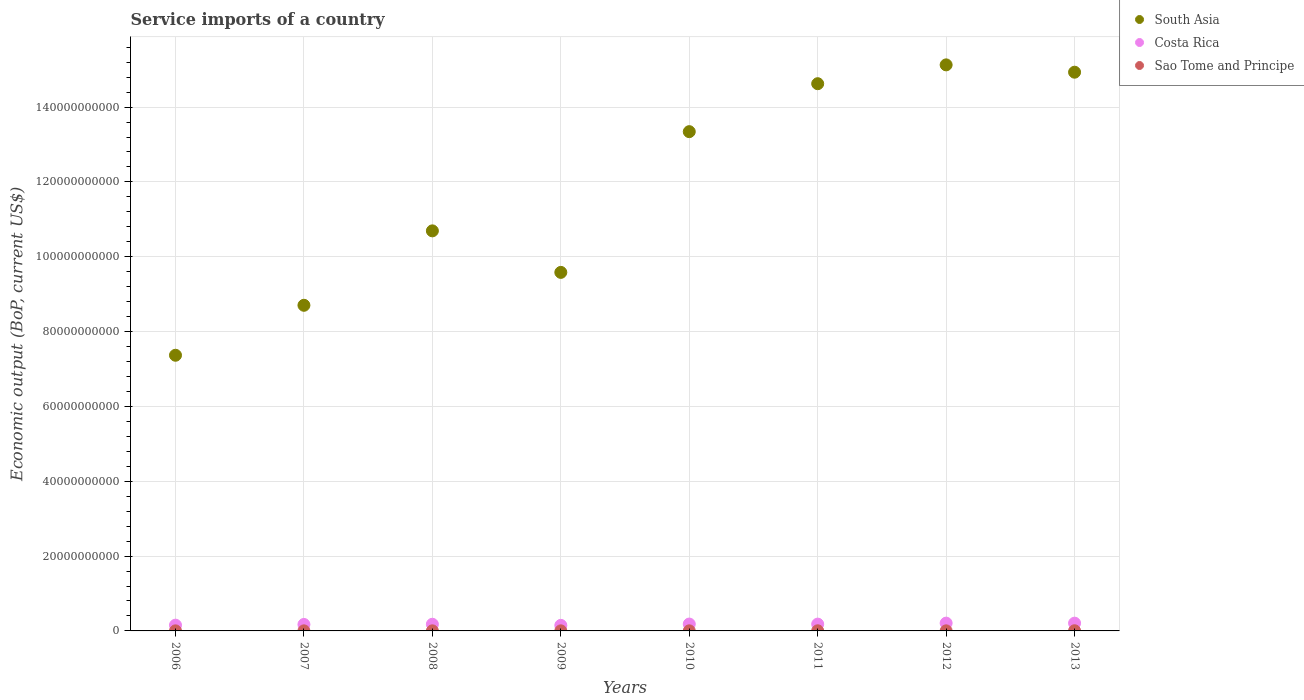How many different coloured dotlines are there?
Make the answer very short. 3. Is the number of dotlines equal to the number of legend labels?
Your response must be concise. Yes. What is the service imports in Costa Rica in 2006?
Keep it short and to the point. 1.54e+09. Across all years, what is the maximum service imports in Costa Rica?
Provide a succinct answer. 2.08e+09. Across all years, what is the minimum service imports in South Asia?
Give a very brief answer. 7.37e+1. In which year was the service imports in Costa Rica minimum?
Provide a short and direct response. 2009. What is the total service imports in Costa Rica in the graph?
Provide a succinct answer. 1.44e+1. What is the difference between the service imports in Costa Rica in 2008 and that in 2013?
Make the answer very short. -2.96e+08. What is the difference between the service imports in South Asia in 2011 and the service imports in Costa Rica in 2007?
Ensure brevity in your answer.  1.45e+11. What is the average service imports in Costa Rica per year?
Ensure brevity in your answer.  1.79e+09. In the year 2012, what is the difference between the service imports in South Asia and service imports in Costa Rica?
Provide a short and direct response. 1.49e+11. In how many years, is the service imports in South Asia greater than 116000000000 US$?
Keep it short and to the point. 4. What is the ratio of the service imports in South Asia in 2008 to that in 2012?
Your response must be concise. 0.71. Is the difference between the service imports in South Asia in 2008 and 2012 greater than the difference between the service imports in Costa Rica in 2008 and 2012?
Keep it short and to the point. No. What is the difference between the highest and the second highest service imports in Costa Rica?
Offer a terse response. 8.37e+06. What is the difference between the highest and the lowest service imports in Costa Rica?
Your answer should be compact. 5.97e+08. Is it the case that in every year, the sum of the service imports in South Asia and service imports in Sao Tome and Principe  is greater than the service imports in Costa Rica?
Ensure brevity in your answer.  Yes. How many years are there in the graph?
Ensure brevity in your answer.  8. Are the values on the major ticks of Y-axis written in scientific E-notation?
Keep it short and to the point. No. Does the graph contain any zero values?
Give a very brief answer. No. How many legend labels are there?
Your answer should be compact. 3. How are the legend labels stacked?
Your answer should be very brief. Vertical. What is the title of the graph?
Make the answer very short. Service imports of a country. Does "Mauritius" appear as one of the legend labels in the graph?
Offer a terse response. No. What is the label or title of the X-axis?
Give a very brief answer. Years. What is the label or title of the Y-axis?
Give a very brief answer. Economic output (BoP, current US$). What is the Economic output (BoP, current US$) in South Asia in 2006?
Offer a terse response. 7.37e+1. What is the Economic output (BoP, current US$) of Costa Rica in 2006?
Keep it short and to the point. 1.54e+09. What is the Economic output (BoP, current US$) in Sao Tome and Principe in 2006?
Offer a very short reply. 1.78e+07. What is the Economic output (BoP, current US$) of South Asia in 2007?
Make the answer very short. 8.70e+1. What is the Economic output (BoP, current US$) of Costa Rica in 2007?
Keep it short and to the point. 1.73e+09. What is the Economic output (BoP, current US$) of Sao Tome and Principe in 2007?
Give a very brief answer. 1.87e+07. What is the Economic output (BoP, current US$) in South Asia in 2008?
Offer a terse response. 1.07e+11. What is the Economic output (BoP, current US$) of Costa Rica in 2008?
Offer a very short reply. 1.78e+09. What is the Economic output (BoP, current US$) in Sao Tome and Principe in 2008?
Provide a short and direct response. 2.14e+07. What is the Economic output (BoP, current US$) in South Asia in 2009?
Give a very brief answer. 9.58e+1. What is the Economic output (BoP, current US$) of Costa Rica in 2009?
Offer a terse response. 1.49e+09. What is the Economic output (BoP, current US$) of Sao Tome and Principe in 2009?
Keep it short and to the point. 1.90e+07. What is the Economic output (BoP, current US$) in South Asia in 2010?
Your answer should be compact. 1.33e+11. What is the Economic output (BoP, current US$) in Costa Rica in 2010?
Provide a short and direct response. 1.84e+09. What is the Economic output (BoP, current US$) of Sao Tome and Principe in 2010?
Ensure brevity in your answer.  2.43e+07. What is the Economic output (BoP, current US$) of South Asia in 2011?
Your answer should be very brief. 1.46e+11. What is the Economic output (BoP, current US$) of Costa Rica in 2011?
Offer a very short reply. 1.82e+09. What is the Economic output (BoP, current US$) in Sao Tome and Principe in 2011?
Provide a succinct answer. 3.14e+07. What is the Economic output (BoP, current US$) in South Asia in 2012?
Ensure brevity in your answer.  1.51e+11. What is the Economic output (BoP, current US$) in Costa Rica in 2012?
Make the answer very short. 2.08e+09. What is the Economic output (BoP, current US$) in Sao Tome and Principe in 2012?
Your response must be concise. 2.46e+07. What is the Economic output (BoP, current US$) in South Asia in 2013?
Your answer should be compact. 1.49e+11. What is the Economic output (BoP, current US$) in Costa Rica in 2013?
Ensure brevity in your answer.  2.08e+09. What is the Economic output (BoP, current US$) in Sao Tome and Principe in 2013?
Keep it short and to the point. 4.49e+07. Across all years, what is the maximum Economic output (BoP, current US$) in South Asia?
Give a very brief answer. 1.51e+11. Across all years, what is the maximum Economic output (BoP, current US$) in Costa Rica?
Ensure brevity in your answer.  2.08e+09. Across all years, what is the maximum Economic output (BoP, current US$) of Sao Tome and Principe?
Your answer should be compact. 4.49e+07. Across all years, what is the minimum Economic output (BoP, current US$) of South Asia?
Ensure brevity in your answer.  7.37e+1. Across all years, what is the minimum Economic output (BoP, current US$) of Costa Rica?
Your response must be concise. 1.49e+09. Across all years, what is the minimum Economic output (BoP, current US$) of Sao Tome and Principe?
Give a very brief answer. 1.78e+07. What is the total Economic output (BoP, current US$) of South Asia in the graph?
Offer a very short reply. 9.44e+11. What is the total Economic output (BoP, current US$) in Costa Rica in the graph?
Keep it short and to the point. 1.44e+1. What is the total Economic output (BoP, current US$) in Sao Tome and Principe in the graph?
Provide a short and direct response. 2.02e+08. What is the difference between the Economic output (BoP, current US$) of South Asia in 2006 and that in 2007?
Your answer should be compact. -1.34e+1. What is the difference between the Economic output (BoP, current US$) in Costa Rica in 2006 and that in 2007?
Ensure brevity in your answer.  -1.88e+08. What is the difference between the Economic output (BoP, current US$) in Sao Tome and Principe in 2006 and that in 2007?
Your answer should be very brief. -9.06e+05. What is the difference between the Economic output (BoP, current US$) of South Asia in 2006 and that in 2008?
Provide a succinct answer. -3.32e+1. What is the difference between the Economic output (BoP, current US$) of Costa Rica in 2006 and that in 2008?
Ensure brevity in your answer.  -2.40e+08. What is the difference between the Economic output (BoP, current US$) in Sao Tome and Principe in 2006 and that in 2008?
Ensure brevity in your answer.  -3.68e+06. What is the difference between the Economic output (BoP, current US$) of South Asia in 2006 and that in 2009?
Your answer should be very brief. -2.21e+1. What is the difference between the Economic output (BoP, current US$) in Costa Rica in 2006 and that in 2009?
Your answer should be compact. 5.21e+07. What is the difference between the Economic output (BoP, current US$) of Sao Tome and Principe in 2006 and that in 2009?
Your answer should be very brief. -1.22e+06. What is the difference between the Economic output (BoP, current US$) of South Asia in 2006 and that in 2010?
Provide a short and direct response. -5.98e+1. What is the difference between the Economic output (BoP, current US$) in Costa Rica in 2006 and that in 2010?
Provide a short and direct response. -2.98e+08. What is the difference between the Economic output (BoP, current US$) of Sao Tome and Principe in 2006 and that in 2010?
Offer a terse response. -6.56e+06. What is the difference between the Economic output (BoP, current US$) in South Asia in 2006 and that in 2011?
Your response must be concise. -7.26e+1. What is the difference between the Economic output (BoP, current US$) in Costa Rica in 2006 and that in 2011?
Keep it short and to the point. -2.82e+08. What is the difference between the Economic output (BoP, current US$) of Sao Tome and Principe in 2006 and that in 2011?
Give a very brief answer. -1.36e+07. What is the difference between the Economic output (BoP, current US$) in South Asia in 2006 and that in 2012?
Offer a very short reply. -7.76e+1. What is the difference between the Economic output (BoP, current US$) in Costa Rica in 2006 and that in 2012?
Your answer should be very brief. -5.45e+08. What is the difference between the Economic output (BoP, current US$) in Sao Tome and Principe in 2006 and that in 2012?
Provide a succinct answer. -6.86e+06. What is the difference between the Economic output (BoP, current US$) of South Asia in 2006 and that in 2013?
Keep it short and to the point. -7.56e+1. What is the difference between the Economic output (BoP, current US$) of Costa Rica in 2006 and that in 2013?
Your answer should be very brief. -5.37e+08. What is the difference between the Economic output (BoP, current US$) in Sao Tome and Principe in 2006 and that in 2013?
Make the answer very short. -2.71e+07. What is the difference between the Economic output (BoP, current US$) in South Asia in 2007 and that in 2008?
Make the answer very short. -1.99e+1. What is the difference between the Economic output (BoP, current US$) of Costa Rica in 2007 and that in 2008?
Provide a short and direct response. -5.26e+07. What is the difference between the Economic output (BoP, current US$) in Sao Tome and Principe in 2007 and that in 2008?
Keep it short and to the point. -2.77e+06. What is the difference between the Economic output (BoP, current US$) of South Asia in 2007 and that in 2009?
Provide a short and direct response. -8.79e+09. What is the difference between the Economic output (BoP, current US$) in Costa Rica in 2007 and that in 2009?
Make the answer very short. 2.40e+08. What is the difference between the Economic output (BoP, current US$) in Sao Tome and Principe in 2007 and that in 2009?
Ensure brevity in your answer.  -3.17e+05. What is the difference between the Economic output (BoP, current US$) of South Asia in 2007 and that in 2010?
Give a very brief answer. -4.64e+1. What is the difference between the Economic output (BoP, current US$) in Costa Rica in 2007 and that in 2010?
Your response must be concise. -1.10e+08. What is the difference between the Economic output (BoP, current US$) of Sao Tome and Principe in 2007 and that in 2010?
Your answer should be very brief. -5.65e+06. What is the difference between the Economic output (BoP, current US$) in South Asia in 2007 and that in 2011?
Your answer should be compact. -5.92e+1. What is the difference between the Economic output (BoP, current US$) of Costa Rica in 2007 and that in 2011?
Give a very brief answer. -9.42e+07. What is the difference between the Economic output (BoP, current US$) in Sao Tome and Principe in 2007 and that in 2011?
Your answer should be compact. -1.27e+07. What is the difference between the Economic output (BoP, current US$) of South Asia in 2007 and that in 2012?
Offer a very short reply. -6.43e+1. What is the difference between the Economic output (BoP, current US$) in Costa Rica in 2007 and that in 2012?
Make the answer very short. -3.57e+08. What is the difference between the Economic output (BoP, current US$) in Sao Tome and Principe in 2007 and that in 2012?
Ensure brevity in your answer.  -5.95e+06. What is the difference between the Economic output (BoP, current US$) in South Asia in 2007 and that in 2013?
Ensure brevity in your answer.  -6.23e+1. What is the difference between the Economic output (BoP, current US$) in Costa Rica in 2007 and that in 2013?
Keep it short and to the point. -3.49e+08. What is the difference between the Economic output (BoP, current US$) of Sao Tome and Principe in 2007 and that in 2013?
Offer a very short reply. -2.62e+07. What is the difference between the Economic output (BoP, current US$) in South Asia in 2008 and that in 2009?
Provide a short and direct response. 1.11e+1. What is the difference between the Economic output (BoP, current US$) in Costa Rica in 2008 and that in 2009?
Your answer should be very brief. 2.92e+08. What is the difference between the Economic output (BoP, current US$) in Sao Tome and Principe in 2008 and that in 2009?
Offer a terse response. 2.45e+06. What is the difference between the Economic output (BoP, current US$) in South Asia in 2008 and that in 2010?
Ensure brevity in your answer.  -2.65e+1. What is the difference between the Economic output (BoP, current US$) of Costa Rica in 2008 and that in 2010?
Provide a succinct answer. -5.72e+07. What is the difference between the Economic output (BoP, current US$) in Sao Tome and Principe in 2008 and that in 2010?
Your response must be concise. -2.88e+06. What is the difference between the Economic output (BoP, current US$) of South Asia in 2008 and that in 2011?
Ensure brevity in your answer.  -3.93e+1. What is the difference between the Economic output (BoP, current US$) of Costa Rica in 2008 and that in 2011?
Your answer should be very brief. -4.16e+07. What is the difference between the Economic output (BoP, current US$) in Sao Tome and Principe in 2008 and that in 2011?
Ensure brevity in your answer.  -9.96e+06. What is the difference between the Economic output (BoP, current US$) in South Asia in 2008 and that in 2012?
Give a very brief answer. -4.44e+1. What is the difference between the Economic output (BoP, current US$) of Costa Rica in 2008 and that in 2012?
Your response must be concise. -3.05e+08. What is the difference between the Economic output (BoP, current US$) of Sao Tome and Principe in 2008 and that in 2012?
Offer a very short reply. -3.18e+06. What is the difference between the Economic output (BoP, current US$) of South Asia in 2008 and that in 2013?
Ensure brevity in your answer.  -4.24e+1. What is the difference between the Economic output (BoP, current US$) of Costa Rica in 2008 and that in 2013?
Provide a succinct answer. -2.96e+08. What is the difference between the Economic output (BoP, current US$) of Sao Tome and Principe in 2008 and that in 2013?
Your answer should be very brief. -2.34e+07. What is the difference between the Economic output (BoP, current US$) of South Asia in 2009 and that in 2010?
Provide a short and direct response. -3.76e+1. What is the difference between the Economic output (BoP, current US$) of Costa Rica in 2009 and that in 2010?
Offer a very short reply. -3.50e+08. What is the difference between the Economic output (BoP, current US$) of Sao Tome and Principe in 2009 and that in 2010?
Offer a very short reply. -5.34e+06. What is the difference between the Economic output (BoP, current US$) in South Asia in 2009 and that in 2011?
Provide a succinct answer. -5.04e+1. What is the difference between the Economic output (BoP, current US$) of Costa Rica in 2009 and that in 2011?
Provide a succinct answer. -3.34e+08. What is the difference between the Economic output (BoP, current US$) in Sao Tome and Principe in 2009 and that in 2011?
Give a very brief answer. -1.24e+07. What is the difference between the Economic output (BoP, current US$) in South Asia in 2009 and that in 2012?
Provide a succinct answer. -5.55e+1. What is the difference between the Economic output (BoP, current US$) of Costa Rica in 2009 and that in 2012?
Offer a very short reply. -5.97e+08. What is the difference between the Economic output (BoP, current US$) in Sao Tome and Principe in 2009 and that in 2012?
Ensure brevity in your answer.  -5.64e+06. What is the difference between the Economic output (BoP, current US$) in South Asia in 2009 and that in 2013?
Your response must be concise. -5.35e+1. What is the difference between the Economic output (BoP, current US$) in Costa Rica in 2009 and that in 2013?
Give a very brief answer. -5.89e+08. What is the difference between the Economic output (BoP, current US$) in Sao Tome and Principe in 2009 and that in 2013?
Offer a very short reply. -2.59e+07. What is the difference between the Economic output (BoP, current US$) of South Asia in 2010 and that in 2011?
Give a very brief answer. -1.28e+1. What is the difference between the Economic output (BoP, current US$) of Costa Rica in 2010 and that in 2011?
Provide a succinct answer. 1.56e+07. What is the difference between the Economic output (BoP, current US$) in Sao Tome and Principe in 2010 and that in 2011?
Your response must be concise. -7.08e+06. What is the difference between the Economic output (BoP, current US$) of South Asia in 2010 and that in 2012?
Provide a succinct answer. -1.78e+1. What is the difference between the Economic output (BoP, current US$) in Costa Rica in 2010 and that in 2012?
Your response must be concise. -2.47e+08. What is the difference between the Economic output (BoP, current US$) in Sao Tome and Principe in 2010 and that in 2012?
Your answer should be very brief. -2.99e+05. What is the difference between the Economic output (BoP, current US$) of South Asia in 2010 and that in 2013?
Provide a short and direct response. -1.59e+1. What is the difference between the Economic output (BoP, current US$) of Costa Rica in 2010 and that in 2013?
Your answer should be very brief. -2.39e+08. What is the difference between the Economic output (BoP, current US$) of Sao Tome and Principe in 2010 and that in 2013?
Keep it short and to the point. -2.06e+07. What is the difference between the Economic output (BoP, current US$) in South Asia in 2011 and that in 2012?
Give a very brief answer. -5.03e+09. What is the difference between the Economic output (BoP, current US$) in Costa Rica in 2011 and that in 2012?
Your response must be concise. -2.63e+08. What is the difference between the Economic output (BoP, current US$) in Sao Tome and Principe in 2011 and that in 2012?
Ensure brevity in your answer.  6.78e+06. What is the difference between the Economic output (BoP, current US$) of South Asia in 2011 and that in 2013?
Give a very brief answer. -3.07e+09. What is the difference between the Economic output (BoP, current US$) in Costa Rica in 2011 and that in 2013?
Offer a very short reply. -2.55e+08. What is the difference between the Economic output (BoP, current US$) in Sao Tome and Principe in 2011 and that in 2013?
Offer a terse response. -1.35e+07. What is the difference between the Economic output (BoP, current US$) in South Asia in 2012 and that in 2013?
Ensure brevity in your answer.  1.96e+09. What is the difference between the Economic output (BoP, current US$) of Costa Rica in 2012 and that in 2013?
Your answer should be compact. 8.37e+06. What is the difference between the Economic output (BoP, current US$) in Sao Tome and Principe in 2012 and that in 2013?
Your answer should be very brief. -2.03e+07. What is the difference between the Economic output (BoP, current US$) in South Asia in 2006 and the Economic output (BoP, current US$) in Costa Rica in 2007?
Offer a terse response. 7.19e+1. What is the difference between the Economic output (BoP, current US$) of South Asia in 2006 and the Economic output (BoP, current US$) of Sao Tome and Principe in 2007?
Make the answer very short. 7.37e+1. What is the difference between the Economic output (BoP, current US$) in Costa Rica in 2006 and the Economic output (BoP, current US$) in Sao Tome and Principe in 2007?
Offer a very short reply. 1.52e+09. What is the difference between the Economic output (BoP, current US$) in South Asia in 2006 and the Economic output (BoP, current US$) in Costa Rica in 2008?
Keep it short and to the point. 7.19e+1. What is the difference between the Economic output (BoP, current US$) in South Asia in 2006 and the Economic output (BoP, current US$) in Sao Tome and Principe in 2008?
Keep it short and to the point. 7.37e+1. What is the difference between the Economic output (BoP, current US$) of Costa Rica in 2006 and the Economic output (BoP, current US$) of Sao Tome and Principe in 2008?
Ensure brevity in your answer.  1.52e+09. What is the difference between the Economic output (BoP, current US$) in South Asia in 2006 and the Economic output (BoP, current US$) in Costa Rica in 2009?
Provide a succinct answer. 7.22e+1. What is the difference between the Economic output (BoP, current US$) of South Asia in 2006 and the Economic output (BoP, current US$) of Sao Tome and Principe in 2009?
Your answer should be very brief. 7.37e+1. What is the difference between the Economic output (BoP, current US$) in Costa Rica in 2006 and the Economic output (BoP, current US$) in Sao Tome and Principe in 2009?
Make the answer very short. 1.52e+09. What is the difference between the Economic output (BoP, current US$) of South Asia in 2006 and the Economic output (BoP, current US$) of Costa Rica in 2010?
Your response must be concise. 7.18e+1. What is the difference between the Economic output (BoP, current US$) in South Asia in 2006 and the Economic output (BoP, current US$) in Sao Tome and Principe in 2010?
Offer a very short reply. 7.37e+1. What is the difference between the Economic output (BoP, current US$) of Costa Rica in 2006 and the Economic output (BoP, current US$) of Sao Tome and Principe in 2010?
Offer a very short reply. 1.51e+09. What is the difference between the Economic output (BoP, current US$) of South Asia in 2006 and the Economic output (BoP, current US$) of Costa Rica in 2011?
Your response must be concise. 7.19e+1. What is the difference between the Economic output (BoP, current US$) of South Asia in 2006 and the Economic output (BoP, current US$) of Sao Tome and Principe in 2011?
Provide a succinct answer. 7.36e+1. What is the difference between the Economic output (BoP, current US$) in Costa Rica in 2006 and the Economic output (BoP, current US$) in Sao Tome and Principe in 2011?
Offer a very short reply. 1.51e+09. What is the difference between the Economic output (BoP, current US$) in South Asia in 2006 and the Economic output (BoP, current US$) in Costa Rica in 2012?
Your answer should be compact. 7.16e+1. What is the difference between the Economic output (BoP, current US$) in South Asia in 2006 and the Economic output (BoP, current US$) in Sao Tome and Principe in 2012?
Your answer should be compact. 7.37e+1. What is the difference between the Economic output (BoP, current US$) of Costa Rica in 2006 and the Economic output (BoP, current US$) of Sao Tome and Principe in 2012?
Keep it short and to the point. 1.51e+09. What is the difference between the Economic output (BoP, current US$) of South Asia in 2006 and the Economic output (BoP, current US$) of Costa Rica in 2013?
Offer a very short reply. 7.16e+1. What is the difference between the Economic output (BoP, current US$) of South Asia in 2006 and the Economic output (BoP, current US$) of Sao Tome and Principe in 2013?
Provide a short and direct response. 7.36e+1. What is the difference between the Economic output (BoP, current US$) of Costa Rica in 2006 and the Economic output (BoP, current US$) of Sao Tome and Principe in 2013?
Your response must be concise. 1.49e+09. What is the difference between the Economic output (BoP, current US$) in South Asia in 2007 and the Economic output (BoP, current US$) in Costa Rica in 2008?
Give a very brief answer. 8.53e+1. What is the difference between the Economic output (BoP, current US$) in South Asia in 2007 and the Economic output (BoP, current US$) in Sao Tome and Principe in 2008?
Give a very brief answer. 8.70e+1. What is the difference between the Economic output (BoP, current US$) in Costa Rica in 2007 and the Economic output (BoP, current US$) in Sao Tome and Principe in 2008?
Provide a succinct answer. 1.71e+09. What is the difference between the Economic output (BoP, current US$) of South Asia in 2007 and the Economic output (BoP, current US$) of Costa Rica in 2009?
Offer a terse response. 8.55e+1. What is the difference between the Economic output (BoP, current US$) of South Asia in 2007 and the Economic output (BoP, current US$) of Sao Tome and Principe in 2009?
Ensure brevity in your answer.  8.70e+1. What is the difference between the Economic output (BoP, current US$) in Costa Rica in 2007 and the Economic output (BoP, current US$) in Sao Tome and Principe in 2009?
Provide a succinct answer. 1.71e+09. What is the difference between the Economic output (BoP, current US$) in South Asia in 2007 and the Economic output (BoP, current US$) in Costa Rica in 2010?
Your response must be concise. 8.52e+1. What is the difference between the Economic output (BoP, current US$) in South Asia in 2007 and the Economic output (BoP, current US$) in Sao Tome and Principe in 2010?
Ensure brevity in your answer.  8.70e+1. What is the difference between the Economic output (BoP, current US$) in Costa Rica in 2007 and the Economic output (BoP, current US$) in Sao Tome and Principe in 2010?
Provide a short and direct response. 1.70e+09. What is the difference between the Economic output (BoP, current US$) of South Asia in 2007 and the Economic output (BoP, current US$) of Costa Rica in 2011?
Provide a succinct answer. 8.52e+1. What is the difference between the Economic output (BoP, current US$) of South Asia in 2007 and the Economic output (BoP, current US$) of Sao Tome and Principe in 2011?
Provide a short and direct response. 8.70e+1. What is the difference between the Economic output (BoP, current US$) of Costa Rica in 2007 and the Economic output (BoP, current US$) of Sao Tome and Principe in 2011?
Provide a succinct answer. 1.70e+09. What is the difference between the Economic output (BoP, current US$) of South Asia in 2007 and the Economic output (BoP, current US$) of Costa Rica in 2012?
Provide a short and direct response. 8.49e+1. What is the difference between the Economic output (BoP, current US$) of South Asia in 2007 and the Economic output (BoP, current US$) of Sao Tome and Principe in 2012?
Make the answer very short. 8.70e+1. What is the difference between the Economic output (BoP, current US$) in Costa Rica in 2007 and the Economic output (BoP, current US$) in Sao Tome and Principe in 2012?
Ensure brevity in your answer.  1.70e+09. What is the difference between the Economic output (BoP, current US$) in South Asia in 2007 and the Economic output (BoP, current US$) in Costa Rica in 2013?
Provide a succinct answer. 8.50e+1. What is the difference between the Economic output (BoP, current US$) of South Asia in 2007 and the Economic output (BoP, current US$) of Sao Tome and Principe in 2013?
Your answer should be very brief. 8.70e+1. What is the difference between the Economic output (BoP, current US$) in Costa Rica in 2007 and the Economic output (BoP, current US$) in Sao Tome and Principe in 2013?
Your answer should be compact. 1.68e+09. What is the difference between the Economic output (BoP, current US$) in South Asia in 2008 and the Economic output (BoP, current US$) in Costa Rica in 2009?
Provide a short and direct response. 1.05e+11. What is the difference between the Economic output (BoP, current US$) in South Asia in 2008 and the Economic output (BoP, current US$) in Sao Tome and Principe in 2009?
Keep it short and to the point. 1.07e+11. What is the difference between the Economic output (BoP, current US$) in Costa Rica in 2008 and the Economic output (BoP, current US$) in Sao Tome and Principe in 2009?
Keep it short and to the point. 1.76e+09. What is the difference between the Economic output (BoP, current US$) in South Asia in 2008 and the Economic output (BoP, current US$) in Costa Rica in 2010?
Your answer should be compact. 1.05e+11. What is the difference between the Economic output (BoP, current US$) in South Asia in 2008 and the Economic output (BoP, current US$) in Sao Tome and Principe in 2010?
Keep it short and to the point. 1.07e+11. What is the difference between the Economic output (BoP, current US$) of Costa Rica in 2008 and the Economic output (BoP, current US$) of Sao Tome and Principe in 2010?
Make the answer very short. 1.76e+09. What is the difference between the Economic output (BoP, current US$) of South Asia in 2008 and the Economic output (BoP, current US$) of Costa Rica in 2011?
Provide a short and direct response. 1.05e+11. What is the difference between the Economic output (BoP, current US$) in South Asia in 2008 and the Economic output (BoP, current US$) in Sao Tome and Principe in 2011?
Offer a terse response. 1.07e+11. What is the difference between the Economic output (BoP, current US$) in Costa Rica in 2008 and the Economic output (BoP, current US$) in Sao Tome and Principe in 2011?
Offer a terse response. 1.75e+09. What is the difference between the Economic output (BoP, current US$) in South Asia in 2008 and the Economic output (BoP, current US$) in Costa Rica in 2012?
Offer a terse response. 1.05e+11. What is the difference between the Economic output (BoP, current US$) in South Asia in 2008 and the Economic output (BoP, current US$) in Sao Tome and Principe in 2012?
Keep it short and to the point. 1.07e+11. What is the difference between the Economic output (BoP, current US$) of Costa Rica in 2008 and the Economic output (BoP, current US$) of Sao Tome and Principe in 2012?
Your answer should be compact. 1.75e+09. What is the difference between the Economic output (BoP, current US$) of South Asia in 2008 and the Economic output (BoP, current US$) of Costa Rica in 2013?
Offer a very short reply. 1.05e+11. What is the difference between the Economic output (BoP, current US$) of South Asia in 2008 and the Economic output (BoP, current US$) of Sao Tome and Principe in 2013?
Your answer should be very brief. 1.07e+11. What is the difference between the Economic output (BoP, current US$) in Costa Rica in 2008 and the Economic output (BoP, current US$) in Sao Tome and Principe in 2013?
Your answer should be compact. 1.73e+09. What is the difference between the Economic output (BoP, current US$) in South Asia in 2009 and the Economic output (BoP, current US$) in Costa Rica in 2010?
Give a very brief answer. 9.40e+1. What is the difference between the Economic output (BoP, current US$) of South Asia in 2009 and the Economic output (BoP, current US$) of Sao Tome and Principe in 2010?
Your answer should be very brief. 9.58e+1. What is the difference between the Economic output (BoP, current US$) of Costa Rica in 2009 and the Economic output (BoP, current US$) of Sao Tome and Principe in 2010?
Provide a short and direct response. 1.46e+09. What is the difference between the Economic output (BoP, current US$) of South Asia in 2009 and the Economic output (BoP, current US$) of Costa Rica in 2011?
Offer a very short reply. 9.40e+1. What is the difference between the Economic output (BoP, current US$) of South Asia in 2009 and the Economic output (BoP, current US$) of Sao Tome and Principe in 2011?
Provide a short and direct response. 9.58e+1. What is the difference between the Economic output (BoP, current US$) of Costa Rica in 2009 and the Economic output (BoP, current US$) of Sao Tome and Principe in 2011?
Offer a terse response. 1.46e+09. What is the difference between the Economic output (BoP, current US$) of South Asia in 2009 and the Economic output (BoP, current US$) of Costa Rica in 2012?
Offer a terse response. 9.37e+1. What is the difference between the Economic output (BoP, current US$) in South Asia in 2009 and the Economic output (BoP, current US$) in Sao Tome and Principe in 2012?
Your answer should be very brief. 9.58e+1. What is the difference between the Economic output (BoP, current US$) in Costa Rica in 2009 and the Economic output (BoP, current US$) in Sao Tome and Principe in 2012?
Provide a short and direct response. 1.46e+09. What is the difference between the Economic output (BoP, current US$) in South Asia in 2009 and the Economic output (BoP, current US$) in Costa Rica in 2013?
Offer a terse response. 9.37e+1. What is the difference between the Economic output (BoP, current US$) in South Asia in 2009 and the Economic output (BoP, current US$) in Sao Tome and Principe in 2013?
Give a very brief answer. 9.58e+1. What is the difference between the Economic output (BoP, current US$) of Costa Rica in 2009 and the Economic output (BoP, current US$) of Sao Tome and Principe in 2013?
Ensure brevity in your answer.  1.44e+09. What is the difference between the Economic output (BoP, current US$) of South Asia in 2010 and the Economic output (BoP, current US$) of Costa Rica in 2011?
Offer a very short reply. 1.32e+11. What is the difference between the Economic output (BoP, current US$) in South Asia in 2010 and the Economic output (BoP, current US$) in Sao Tome and Principe in 2011?
Offer a very short reply. 1.33e+11. What is the difference between the Economic output (BoP, current US$) of Costa Rica in 2010 and the Economic output (BoP, current US$) of Sao Tome and Principe in 2011?
Provide a succinct answer. 1.81e+09. What is the difference between the Economic output (BoP, current US$) of South Asia in 2010 and the Economic output (BoP, current US$) of Costa Rica in 2012?
Keep it short and to the point. 1.31e+11. What is the difference between the Economic output (BoP, current US$) of South Asia in 2010 and the Economic output (BoP, current US$) of Sao Tome and Principe in 2012?
Provide a succinct answer. 1.33e+11. What is the difference between the Economic output (BoP, current US$) in Costa Rica in 2010 and the Economic output (BoP, current US$) in Sao Tome and Principe in 2012?
Provide a short and direct response. 1.81e+09. What is the difference between the Economic output (BoP, current US$) in South Asia in 2010 and the Economic output (BoP, current US$) in Costa Rica in 2013?
Give a very brief answer. 1.31e+11. What is the difference between the Economic output (BoP, current US$) in South Asia in 2010 and the Economic output (BoP, current US$) in Sao Tome and Principe in 2013?
Make the answer very short. 1.33e+11. What is the difference between the Economic output (BoP, current US$) of Costa Rica in 2010 and the Economic output (BoP, current US$) of Sao Tome and Principe in 2013?
Your answer should be very brief. 1.79e+09. What is the difference between the Economic output (BoP, current US$) of South Asia in 2011 and the Economic output (BoP, current US$) of Costa Rica in 2012?
Your answer should be very brief. 1.44e+11. What is the difference between the Economic output (BoP, current US$) of South Asia in 2011 and the Economic output (BoP, current US$) of Sao Tome and Principe in 2012?
Offer a terse response. 1.46e+11. What is the difference between the Economic output (BoP, current US$) in Costa Rica in 2011 and the Economic output (BoP, current US$) in Sao Tome and Principe in 2012?
Offer a very short reply. 1.80e+09. What is the difference between the Economic output (BoP, current US$) of South Asia in 2011 and the Economic output (BoP, current US$) of Costa Rica in 2013?
Your response must be concise. 1.44e+11. What is the difference between the Economic output (BoP, current US$) in South Asia in 2011 and the Economic output (BoP, current US$) in Sao Tome and Principe in 2013?
Make the answer very short. 1.46e+11. What is the difference between the Economic output (BoP, current US$) of Costa Rica in 2011 and the Economic output (BoP, current US$) of Sao Tome and Principe in 2013?
Provide a succinct answer. 1.78e+09. What is the difference between the Economic output (BoP, current US$) of South Asia in 2012 and the Economic output (BoP, current US$) of Costa Rica in 2013?
Your answer should be compact. 1.49e+11. What is the difference between the Economic output (BoP, current US$) in South Asia in 2012 and the Economic output (BoP, current US$) in Sao Tome and Principe in 2013?
Offer a terse response. 1.51e+11. What is the difference between the Economic output (BoP, current US$) of Costa Rica in 2012 and the Economic output (BoP, current US$) of Sao Tome and Principe in 2013?
Your response must be concise. 2.04e+09. What is the average Economic output (BoP, current US$) of South Asia per year?
Provide a succinct answer. 1.18e+11. What is the average Economic output (BoP, current US$) of Costa Rica per year?
Your answer should be compact. 1.79e+09. What is the average Economic output (BoP, current US$) of Sao Tome and Principe per year?
Provide a succinct answer. 2.53e+07. In the year 2006, what is the difference between the Economic output (BoP, current US$) in South Asia and Economic output (BoP, current US$) in Costa Rica?
Your answer should be compact. 7.21e+1. In the year 2006, what is the difference between the Economic output (BoP, current US$) of South Asia and Economic output (BoP, current US$) of Sao Tome and Principe?
Your answer should be very brief. 7.37e+1. In the year 2006, what is the difference between the Economic output (BoP, current US$) in Costa Rica and Economic output (BoP, current US$) in Sao Tome and Principe?
Offer a terse response. 1.52e+09. In the year 2007, what is the difference between the Economic output (BoP, current US$) in South Asia and Economic output (BoP, current US$) in Costa Rica?
Your response must be concise. 8.53e+1. In the year 2007, what is the difference between the Economic output (BoP, current US$) in South Asia and Economic output (BoP, current US$) in Sao Tome and Principe?
Make the answer very short. 8.70e+1. In the year 2007, what is the difference between the Economic output (BoP, current US$) of Costa Rica and Economic output (BoP, current US$) of Sao Tome and Principe?
Make the answer very short. 1.71e+09. In the year 2008, what is the difference between the Economic output (BoP, current US$) of South Asia and Economic output (BoP, current US$) of Costa Rica?
Offer a terse response. 1.05e+11. In the year 2008, what is the difference between the Economic output (BoP, current US$) of South Asia and Economic output (BoP, current US$) of Sao Tome and Principe?
Ensure brevity in your answer.  1.07e+11. In the year 2008, what is the difference between the Economic output (BoP, current US$) of Costa Rica and Economic output (BoP, current US$) of Sao Tome and Principe?
Provide a succinct answer. 1.76e+09. In the year 2009, what is the difference between the Economic output (BoP, current US$) in South Asia and Economic output (BoP, current US$) in Costa Rica?
Your answer should be compact. 9.43e+1. In the year 2009, what is the difference between the Economic output (BoP, current US$) of South Asia and Economic output (BoP, current US$) of Sao Tome and Principe?
Your answer should be compact. 9.58e+1. In the year 2009, what is the difference between the Economic output (BoP, current US$) in Costa Rica and Economic output (BoP, current US$) in Sao Tome and Principe?
Make the answer very short. 1.47e+09. In the year 2010, what is the difference between the Economic output (BoP, current US$) of South Asia and Economic output (BoP, current US$) of Costa Rica?
Give a very brief answer. 1.32e+11. In the year 2010, what is the difference between the Economic output (BoP, current US$) of South Asia and Economic output (BoP, current US$) of Sao Tome and Principe?
Offer a terse response. 1.33e+11. In the year 2010, what is the difference between the Economic output (BoP, current US$) of Costa Rica and Economic output (BoP, current US$) of Sao Tome and Principe?
Give a very brief answer. 1.81e+09. In the year 2011, what is the difference between the Economic output (BoP, current US$) of South Asia and Economic output (BoP, current US$) of Costa Rica?
Offer a very short reply. 1.44e+11. In the year 2011, what is the difference between the Economic output (BoP, current US$) of South Asia and Economic output (BoP, current US$) of Sao Tome and Principe?
Ensure brevity in your answer.  1.46e+11. In the year 2011, what is the difference between the Economic output (BoP, current US$) in Costa Rica and Economic output (BoP, current US$) in Sao Tome and Principe?
Your response must be concise. 1.79e+09. In the year 2012, what is the difference between the Economic output (BoP, current US$) of South Asia and Economic output (BoP, current US$) of Costa Rica?
Your answer should be compact. 1.49e+11. In the year 2012, what is the difference between the Economic output (BoP, current US$) of South Asia and Economic output (BoP, current US$) of Sao Tome and Principe?
Ensure brevity in your answer.  1.51e+11. In the year 2012, what is the difference between the Economic output (BoP, current US$) in Costa Rica and Economic output (BoP, current US$) in Sao Tome and Principe?
Make the answer very short. 2.06e+09. In the year 2013, what is the difference between the Economic output (BoP, current US$) of South Asia and Economic output (BoP, current US$) of Costa Rica?
Ensure brevity in your answer.  1.47e+11. In the year 2013, what is the difference between the Economic output (BoP, current US$) in South Asia and Economic output (BoP, current US$) in Sao Tome and Principe?
Keep it short and to the point. 1.49e+11. In the year 2013, what is the difference between the Economic output (BoP, current US$) in Costa Rica and Economic output (BoP, current US$) in Sao Tome and Principe?
Offer a very short reply. 2.03e+09. What is the ratio of the Economic output (BoP, current US$) in South Asia in 2006 to that in 2007?
Your answer should be very brief. 0.85. What is the ratio of the Economic output (BoP, current US$) in Costa Rica in 2006 to that in 2007?
Make the answer very short. 0.89. What is the ratio of the Economic output (BoP, current US$) of Sao Tome and Principe in 2006 to that in 2007?
Provide a succinct answer. 0.95. What is the ratio of the Economic output (BoP, current US$) in South Asia in 2006 to that in 2008?
Provide a short and direct response. 0.69. What is the ratio of the Economic output (BoP, current US$) of Costa Rica in 2006 to that in 2008?
Provide a short and direct response. 0.86. What is the ratio of the Economic output (BoP, current US$) in Sao Tome and Principe in 2006 to that in 2008?
Give a very brief answer. 0.83. What is the ratio of the Economic output (BoP, current US$) in South Asia in 2006 to that in 2009?
Your answer should be very brief. 0.77. What is the ratio of the Economic output (BoP, current US$) of Costa Rica in 2006 to that in 2009?
Ensure brevity in your answer.  1.03. What is the ratio of the Economic output (BoP, current US$) of Sao Tome and Principe in 2006 to that in 2009?
Give a very brief answer. 0.94. What is the ratio of the Economic output (BoP, current US$) of South Asia in 2006 to that in 2010?
Your answer should be very brief. 0.55. What is the ratio of the Economic output (BoP, current US$) of Costa Rica in 2006 to that in 2010?
Keep it short and to the point. 0.84. What is the ratio of the Economic output (BoP, current US$) of Sao Tome and Principe in 2006 to that in 2010?
Ensure brevity in your answer.  0.73. What is the ratio of the Economic output (BoP, current US$) of South Asia in 2006 to that in 2011?
Keep it short and to the point. 0.5. What is the ratio of the Economic output (BoP, current US$) in Costa Rica in 2006 to that in 2011?
Ensure brevity in your answer.  0.85. What is the ratio of the Economic output (BoP, current US$) of Sao Tome and Principe in 2006 to that in 2011?
Your answer should be very brief. 0.57. What is the ratio of the Economic output (BoP, current US$) in South Asia in 2006 to that in 2012?
Provide a succinct answer. 0.49. What is the ratio of the Economic output (BoP, current US$) in Costa Rica in 2006 to that in 2012?
Your answer should be compact. 0.74. What is the ratio of the Economic output (BoP, current US$) in Sao Tome and Principe in 2006 to that in 2012?
Ensure brevity in your answer.  0.72. What is the ratio of the Economic output (BoP, current US$) of South Asia in 2006 to that in 2013?
Keep it short and to the point. 0.49. What is the ratio of the Economic output (BoP, current US$) of Costa Rica in 2006 to that in 2013?
Offer a very short reply. 0.74. What is the ratio of the Economic output (BoP, current US$) of Sao Tome and Principe in 2006 to that in 2013?
Keep it short and to the point. 0.4. What is the ratio of the Economic output (BoP, current US$) of South Asia in 2007 to that in 2008?
Make the answer very short. 0.81. What is the ratio of the Economic output (BoP, current US$) in Costa Rica in 2007 to that in 2008?
Keep it short and to the point. 0.97. What is the ratio of the Economic output (BoP, current US$) of Sao Tome and Principe in 2007 to that in 2008?
Give a very brief answer. 0.87. What is the ratio of the Economic output (BoP, current US$) of South Asia in 2007 to that in 2009?
Give a very brief answer. 0.91. What is the ratio of the Economic output (BoP, current US$) of Costa Rica in 2007 to that in 2009?
Make the answer very short. 1.16. What is the ratio of the Economic output (BoP, current US$) of Sao Tome and Principe in 2007 to that in 2009?
Provide a short and direct response. 0.98. What is the ratio of the Economic output (BoP, current US$) in South Asia in 2007 to that in 2010?
Ensure brevity in your answer.  0.65. What is the ratio of the Economic output (BoP, current US$) in Costa Rica in 2007 to that in 2010?
Your answer should be compact. 0.94. What is the ratio of the Economic output (BoP, current US$) in Sao Tome and Principe in 2007 to that in 2010?
Your answer should be very brief. 0.77. What is the ratio of the Economic output (BoP, current US$) in South Asia in 2007 to that in 2011?
Provide a succinct answer. 0.6. What is the ratio of the Economic output (BoP, current US$) of Costa Rica in 2007 to that in 2011?
Ensure brevity in your answer.  0.95. What is the ratio of the Economic output (BoP, current US$) of Sao Tome and Principe in 2007 to that in 2011?
Give a very brief answer. 0.59. What is the ratio of the Economic output (BoP, current US$) in South Asia in 2007 to that in 2012?
Ensure brevity in your answer.  0.58. What is the ratio of the Economic output (BoP, current US$) in Costa Rica in 2007 to that in 2012?
Your answer should be compact. 0.83. What is the ratio of the Economic output (BoP, current US$) of Sao Tome and Principe in 2007 to that in 2012?
Provide a succinct answer. 0.76. What is the ratio of the Economic output (BoP, current US$) of South Asia in 2007 to that in 2013?
Keep it short and to the point. 0.58. What is the ratio of the Economic output (BoP, current US$) of Costa Rica in 2007 to that in 2013?
Your answer should be very brief. 0.83. What is the ratio of the Economic output (BoP, current US$) in Sao Tome and Principe in 2007 to that in 2013?
Provide a succinct answer. 0.42. What is the ratio of the Economic output (BoP, current US$) in South Asia in 2008 to that in 2009?
Make the answer very short. 1.12. What is the ratio of the Economic output (BoP, current US$) of Costa Rica in 2008 to that in 2009?
Offer a terse response. 1.2. What is the ratio of the Economic output (BoP, current US$) of Sao Tome and Principe in 2008 to that in 2009?
Ensure brevity in your answer.  1.13. What is the ratio of the Economic output (BoP, current US$) of South Asia in 2008 to that in 2010?
Provide a succinct answer. 0.8. What is the ratio of the Economic output (BoP, current US$) of Costa Rica in 2008 to that in 2010?
Keep it short and to the point. 0.97. What is the ratio of the Economic output (BoP, current US$) in Sao Tome and Principe in 2008 to that in 2010?
Provide a succinct answer. 0.88. What is the ratio of the Economic output (BoP, current US$) of South Asia in 2008 to that in 2011?
Provide a short and direct response. 0.73. What is the ratio of the Economic output (BoP, current US$) of Costa Rica in 2008 to that in 2011?
Ensure brevity in your answer.  0.98. What is the ratio of the Economic output (BoP, current US$) of Sao Tome and Principe in 2008 to that in 2011?
Ensure brevity in your answer.  0.68. What is the ratio of the Economic output (BoP, current US$) of South Asia in 2008 to that in 2012?
Offer a very short reply. 0.71. What is the ratio of the Economic output (BoP, current US$) in Costa Rica in 2008 to that in 2012?
Make the answer very short. 0.85. What is the ratio of the Economic output (BoP, current US$) of Sao Tome and Principe in 2008 to that in 2012?
Offer a very short reply. 0.87. What is the ratio of the Economic output (BoP, current US$) in South Asia in 2008 to that in 2013?
Ensure brevity in your answer.  0.72. What is the ratio of the Economic output (BoP, current US$) of Costa Rica in 2008 to that in 2013?
Provide a succinct answer. 0.86. What is the ratio of the Economic output (BoP, current US$) in Sao Tome and Principe in 2008 to that in 2013?
Provide a succinct answer. 0.48. What is the ratio of the Economic output (BoP, current US$) in South Asia in 2009 to that in 2010?
Make the answer very short. 0.72. What is the ratio of the Economic output (BoP, current US$) of Costa Rica in 2009 to that in 2010?
Make the answer very short. 0.81. What is the ratio of the Economic output (BoP, current US$) in Sao Tome and Principe in 2009 to that in 2010?
Provide a succinct answer. 0.78. What is the ratio of the Economic output (BoP, current US$) of South Asia in 2009 to that in 2011?
Give a very brief answer. 0.66. What is the ratio of the Economic output (BoP, current US$) of Costa Rica in 2009 to that in 2011?
Give a very brief answer. 0.82. What is the ratio of the Economic output (BoP, current US$) of Sao Tome and Principe in 2009 to that in 2011?
Offer a very short reply. 0.6. What is the ratio of the Economic output (BoP, current US$) in South Asia in 2009 to that in 2012?
Your response must be concise. 0.63. What is the ratio of the Economic output (BoP, current US$) in Costa Rica in 2009 to that in 2012?
Offer a very short reply. 0.71. What is the ratio of the Economic output (BoP, current US$) in Sao Tome and Principe in 2009 to that in 2012?
Ensure brevity in your answer.  0.77. What is the ratio of the Economic output (BoP, current US$) in South Asia in 2009 to that in 2013?
Give a very brief answer. 0.64. What is the ratio of the Economic output (BoP, current US$) of Costa Rica in 2009 to that in 2013?
Make the answer very short. 0.72. What is the ratio of the Economic output (BoP, current US$) of Sao Tome and Principe in 2009 to that in 2013?
Your answer should be compact. 0.42. What is the ratio of the Economic output (BoP, current US$) of South Asia in 2010 to that in 2011?
Provide a short and direct response. 0.91. What is the ratio of the Economic output (BoP, current US$) in Costa Rica in 2010 to that in 2011?
Offer a terse response. 1.01. What is the ratio of the Economic output (BoP, current US$) in Sao Tome and Principe in 2010 to that in 2011?
Your answer should be compact. 0.77. What is the ratio of the Economic output (BoP, current US$) of South Asia in 2010 to that in 2012?
Your response must be concise. 0.88. What is the ratio of the Economic output (BoP, current US$) in Costa Rica in 2010 to that in 2012?
Provide a short and direct response. 0.88. What is the ratio of the Economic output (BoP, current US$) of South Asia in 2010 to that in 2013?
Ensure brevity in your answer.  0.89. What is the ratio of the Economic output (BoP, current US$) in Costa Rica in 2010 to that in 2013?
Your answer should be very brief. 0.88. What is the ratio of the Economic output (BoP, current US$) in Sao Tome and Principe in 2010 to that in 2013?
Ensure brevity in your answer.  0.54. What is the ratio of the Economic output (BoP, current US$) of South Asia in 2011 to that in 2012?
Make the answer very short. 0.97. What is the ratio of the Economic output (BoP, current US$) of Costa Rica in 2011 to that in 2012?
Offer a very short reply. 0.87. What is the ratio of the Economic output (BoP, current US$) of Sao Tome and Principe in 2011 to that in 2012?
Ensure brevity in your answer.  1.28. What is the ratio of the Economic output (BoP, current US$) in South Asia in 2011 to that in 2013?
Your answer should be very brief. 0.98. What is the ratio of the Economic output (BoP, current US$) of Costa Rica in 2011 to that in 2013?
Offer a terse response. 0.88. What is the ratio of the Economic output (BoP, current US$) in Sao Tome and Principe in 2011 to that in 2013?
Your response must be concise. 0.7. What is the ratio of the Economic output (BoP, current US$) in South Asia in 2012 to that in 2013?
Offer a terse response. 1.01. What is the ratio of the Economic output (BoP, current US$) in Costa Rica in 2012 to that in 2013?
Give a very brief answer. 1. What is the ratio of the Economic output (BoP, current US$) in Sao Tome and Principe in 2012 to that in 2013?
Make the answer very short. 0.55. What is the difference between the highest and the second highest Economic output (BoP, current US$) in South Asia?
Offer a very short reply. 1.96e+09. What is the difference between the highest and the second highest Economic output (BoP, current US$) of Costa Rica?
Provide a succinct answer. 8.37e+06. What is the difference between the highest and the second highest Economic output (BoP, current US$) in Sao Tome and Principe?
Provide a short and direct response. 1.35e+07. What is the difference between the highest and the lowest Economic output (BoP, current US$) of South Asia?
Give a very brief answer. 7.76e+1. What is the difference between the highest and the lowest Economic output (BoP, current US$) of Costa Rica?
Your response must be concise. 5.97e+08. What is the difference between the highest and the lowest Economic output (BoP, current US$) of Sao Tome and Principe?
Offer a very short reply. 2.71e+07. 